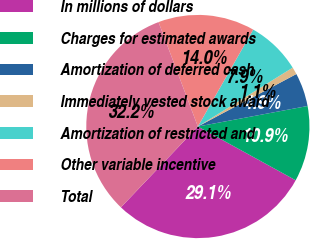<chart> <loc_0><loc_0><loc_500><loc_500><pie_chart><fcel>In millions of dollars<fcel>Charges for estimated awards<fcel>Amortization of deferred cash<fcel>Immediately vested stock award<fcel>Amortization of restricted and<fcel>Other variable incentive<fcel>Total<nl><fcel>29.11%<fcel>10.94%<fcel>4.85%<fcel>1.05%<fcel>7.9%<fcel>13.99%<fcel>32.15%<nl></chart> 